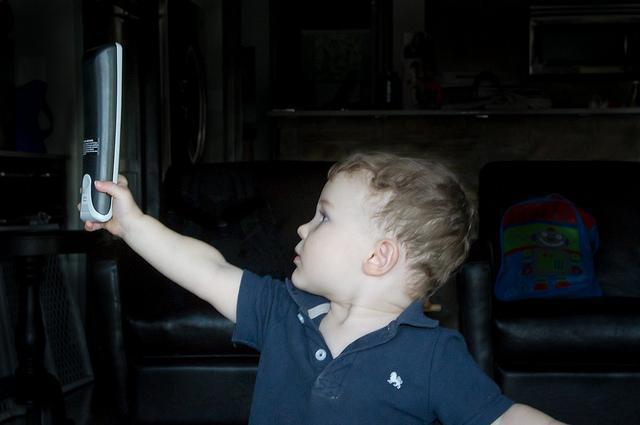How many children are there?
Give a very brief answer. 1. How many children are present?
Give a very brief answer. 1. How many people are in the photo?
Give a very brief answer. 1. How many chairs are in the photo?
Give a very brief answer. 2. How many microwaves can you see?
Give a very brief answer. 1. 